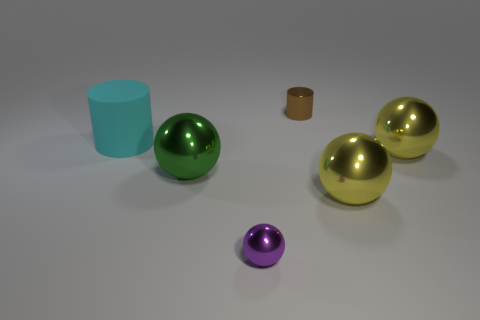Subtract all small purple metal spheres. How many spheres are left? 3 Add 2 tiny brown things. How many objects exist? 8 Subtract 0 purple cylinders. How many objects are left? 6 Subtract all cylinders. How many objects are left? 4 Subtract 2 cylinders. How many cylinders are left? 0 Subtract all green balls. Subtract all gray cubes. How many balls are left? 3 Subtract all green spheres. How many gray cylinders are left? 0 Subtract all big yellow spheres. Subtract all yellow things. How many objects are left? 2 Add 4 green things. How many green things are left? 5 Add 4 yellow metallic objects. How many yellow metallic objects exist? 6 